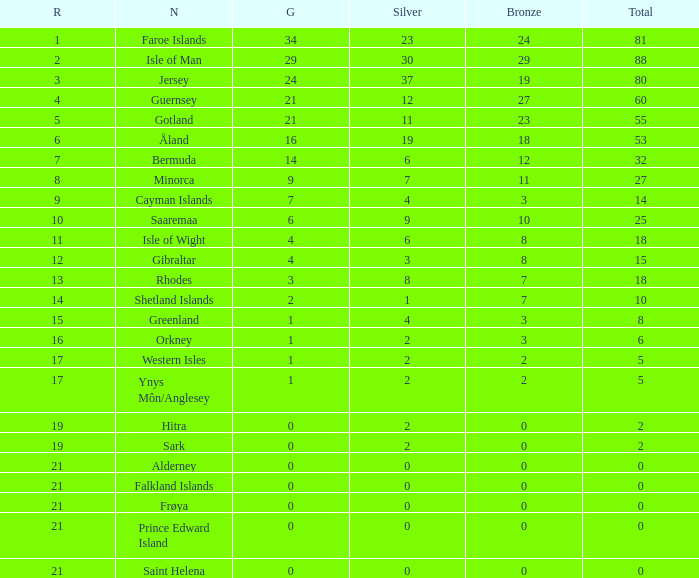Write the full table. {'header': ['R', 'N', 'G', 'Silver', 'Bronze', 'Total'], 'rows': [['1', 'Faroe Islands', '34', '23', '24', '81'], ['2', 'Isle of Man', '29', '30', '29', '88'], ['3', 'Jersey', '24', '37', '19', '80'], ['4', 'Guernsey', '21', '12', '27', '60'], ['5', 'Gotland', '21', '11', '23', '55'], ['6', 'Åland', '16', '19', '18', '53'], ['7', 'Bermuda', '14', '6', '12', '32'], ['8', 'Minorca', '9', '7', '11', '27'], ['9', 'Cayman Islands', '7', '4', '3', '14'], ['10', 'Saaremaa', '6', '9', '10', '25'], ['11', 'Isle of Wight', '4', '6', '8', '18'], ['12', 'Gibraltar', '4', '3', '8', '15'], ['13', 'Rhodes', '3', '8', '7', '18'], ['14', 'Shetland Islands', '2', '1', '7', '10'], ['15', 'Greenland', '1', '4', '3', '8'], ['16', 'Orkney', '1', '2', '3', '6'], ['17', 'Western Isles', '1', '2', '2', '5'], ['17', 'Ynys Môn/Anglesey', '1', '2', '2', '5'], ['19', 'Hitra', '0', '2', '0', '2'], ['19', 'Sark', '0', '2', '0', '2'], ['21', 'Alderney', '0', '0', '0', '0'], ['21', 'Falkland Islands', '0', '0', '0', '0'], ['21', 'Frøya', '0', '0', '0', '0'], ['21', 'Prince Edward Island', '0', '0', '0', '0'], ['21', 'Saint Helena', '0', '0', '0', '0']]} How many Silver medals were won in total by all those with more than 3 bronze and exactly 16 gold? 19.0. 